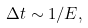<formula> <loc_0><loc_0><loc_500><loc_500>\Delta t \sim 1 / E ,</formula> 